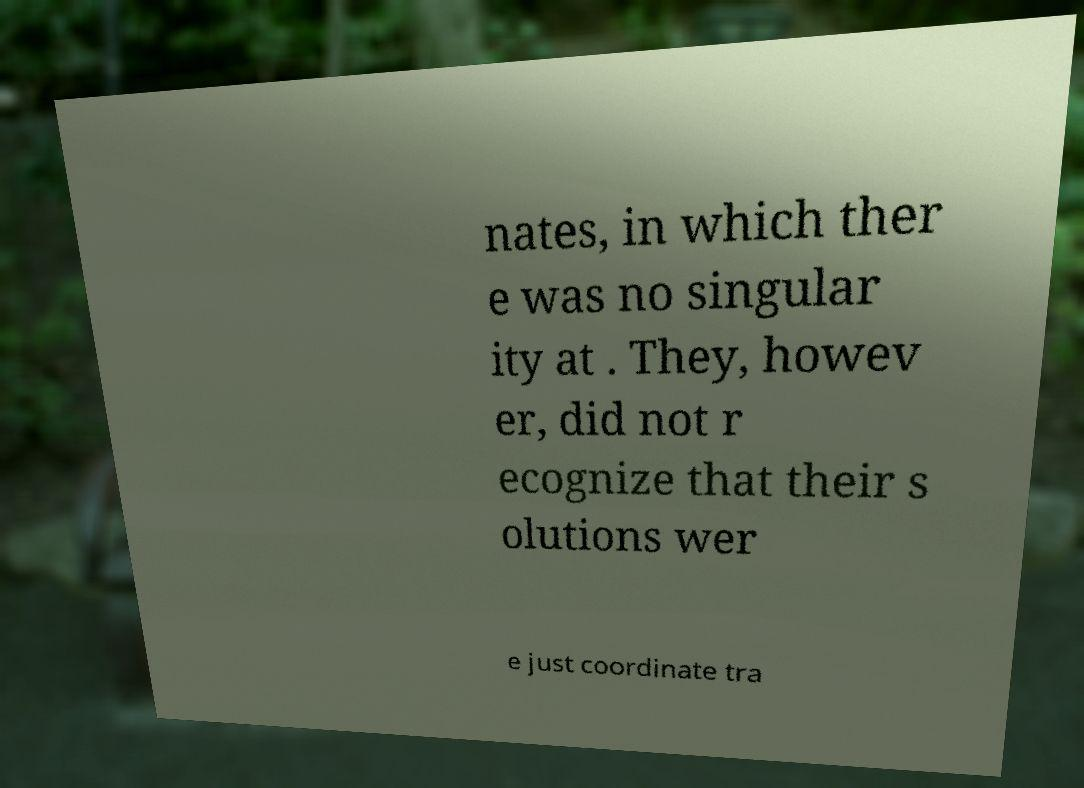There's text embedded in this image that I need extracted. Can you transcribe it verbatim? nates, in which ther e was no singular ity at . They, howev er, did not r ecognize that their s olutions wer e just coordinate tra 